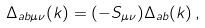Convert formula to latex. <formula><loc_0><loc_0><loc_500><loc_500>\Delta _ { a b \mu \nu } ( k ) = ( - S _ { \mu \nu } ) \Delta _ { a b } ( k ) \, ,</formula> 